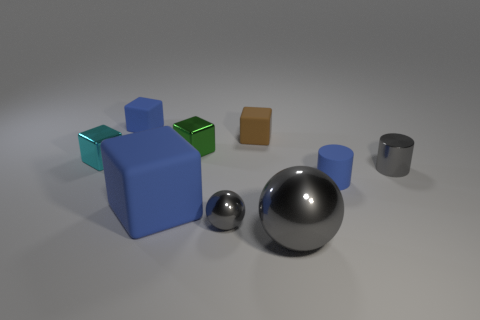What is the shape of the tiny blue object on the right side of the tiny blue thing left of the large blue cube?
Provide a succinct answer. Cylinder. What shape is the gray shiny object that is the same size as the gray shiny cylinder?
Provide a succinct answer. Sphere. Are there any large gray metallic things that have the same shape as the tiny cyan thing?
Offer a very short reply. No. What is the large gray object made of?
Provide a succinct answer. Metal. There is a big sphere; are there any small matte cylinders to the left of it?
Your response must be concise. No. How many small blue cylinders are behind the gray metal ball left of the small brown block?
Ensure brevity in your answer.  1. There is a blue block that is the same size as the cyan metal object; what material is it?
Your answer should be compact. Rubber. What number of other objects are there of the same material as the tiny cyan object?
Ensure brevity in your answer.  4. What number of large rubber blocks are behind the cyan shiny thing?
Your response must be concise. 0. How many blocks are purple shiny objects or large gray shiny objects?
Your answer should be compact. 0. 